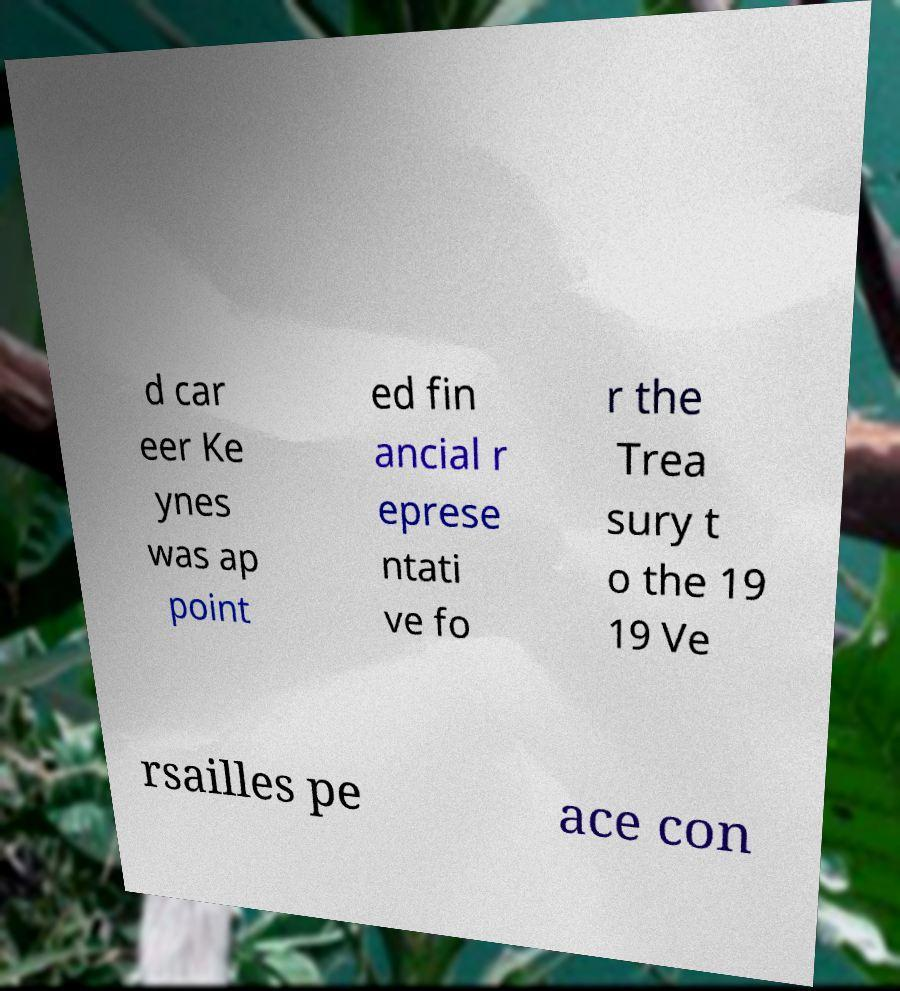Please identify and transcribe the text found in this image. d car eer Ke ynes was ap point ed fin ancial r eprese ntati ve fo r the Trea sury t o the 19 19 Ve rsailles pe ace con 